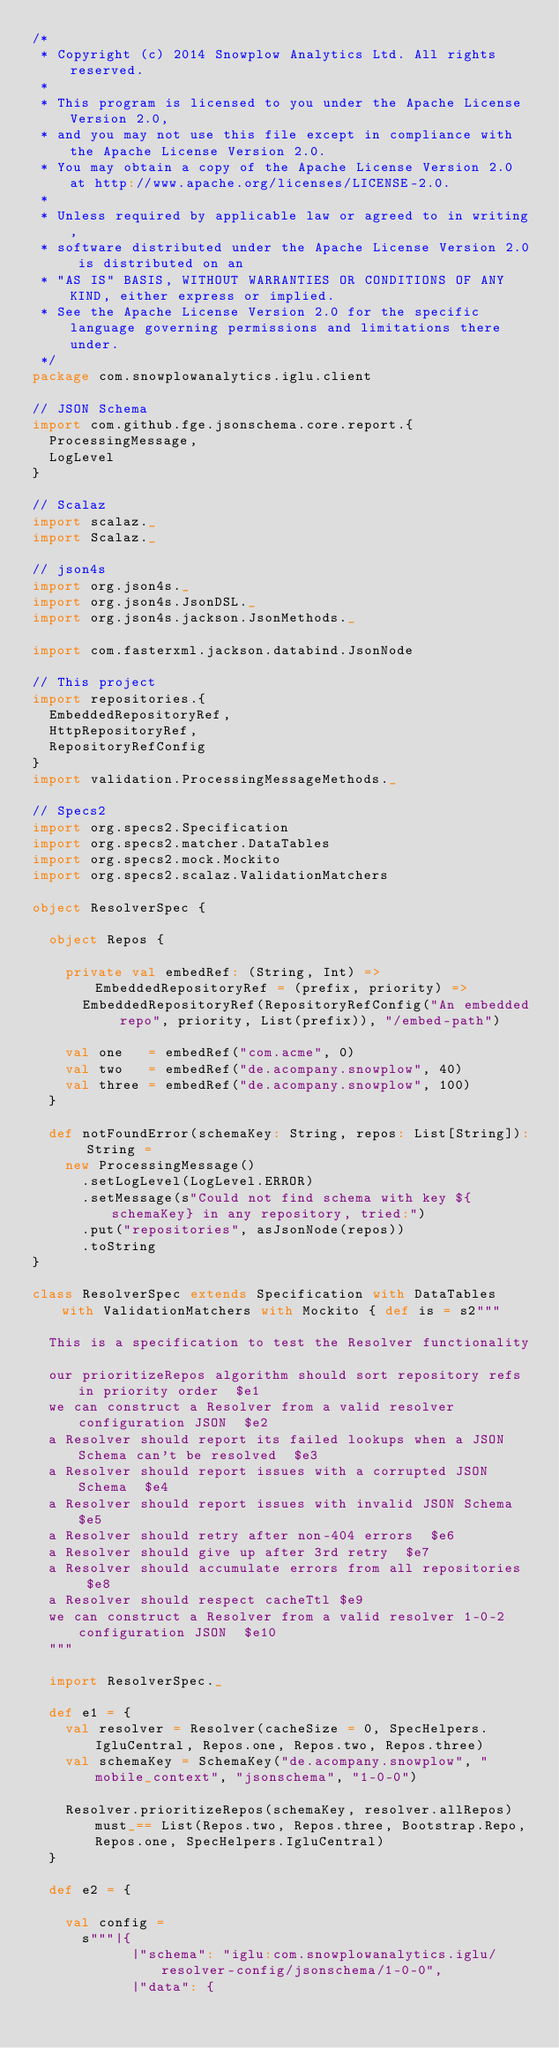Convert code to text. <code><loc_0><loc_0><loc_500><loc_500><_Scala_>/*
 * Copyright (c) 2014 Snowplow Analytics Ltd. All rights reserved.
 *
 * This program is licensed to you under the Apache License Version 2.0,
 * and you may not use this file except in compliance with the Apache License Version 2.0.
 * You may obtain a copy of the Apache License Version 2.0 at http://www.apache.org/licenses/LICENSE-2.0.
 *
 * Unless required by applicable law or agreed to in writing,
 * software distributed under the Apache License Version 2.0 is distributed on an
 * "AS IS" BASIS, WITHOUT WARRANTIES OR CONDITIONS OF ANY KIND, either express or implied.
 * See the Apache License Version 2.0 for the specific language governing permissions and limitations there under.
 */
package com.snowplowanalytics.iglu.client

// JSON Schema
import com.github.fge.jsonschema.core.report.{
  ProcessingMessage,
  LogLevel
}

// Scalaz
import scalaz._
import Scalaz._

// json4s
import org.json4s._
import org.json4s.JsonDSL._
import org.json4s.jackson.JsonMethods._

import com.fasterxml.jackson.databind.JsonNode

// This project
import repositories.{
  EmbeddedRepositoryRef,
  HttpRepositoryRef,
  RepositoryRefConfig
}
import validation.ProcessingMessageMethods._

// Specs2
import org.specs2.Specification
import org.specs2.matcher.DataTables
import org.specs2.mock.Mockito
import org.specs2.scalaz.ValidationMatchers

object ResolverSpec {

  object Repos { 

    private val embedRef: (String, Int) => EmbeddedRepositoryRef = (prefix, priority) =>
      EmbeddedRepositoryRef(RepositoryRefConfig("An embedded repo", priority, List(prefix)), "/embed-path")

    val one   = embedRef("com.acme", 0)
    val two   = embedRef("de.acompany.snowplow", 40)
    val three = embedRef("de.acompany.snowplow", 100)
  }

  def notFoundError(schemaKey: String, repos: List[String]): String =
    new ProcessingMessage()
      .setLogLevel(LogLevel.ERROR)
      .setMessage(s"Could not find schema with key ${schemaKey} in any repository, tried:")
      .put("repositories", asJsonNode(repos))
      .toString
}

class ResolverSpec extends Specification with DataTables with ValidationMatchers with Mockito { def is = s2"""

  This is a specification to test the Resolver functionality

  our prioritizeRepos algorithm should sort repository refs in priority order  $e1
  we can construct a Resolver from a valid resolver configuration JSON  $e2
  a Resolver should report its failed lookups when a JSON Schema can't be resolved  $e3
  a Resolver should report issues with a corrupted JSON Schema  $e4
  a Resolver should report issues with invalid JSON Schema  $e5
  a Resolver should retry after non-404 errors  $e6
  a Resolver should give up after 3rd retry  $e7
  a Resolver should accumulate errors from all repositories  $e8
  a Resolver should respect cacheTtl $e9
  we can construct a Resolver from a valid resolver 1-0-2 configuration JSON  $e10
  """

  import ResolverSpec._

  def e1 = {
    val resolver = Resolver(cacheSize = 0, SpecHelpers.IgluCentral, Repos.one, Repos.two, Repos.three)
    val schemaKey = SchemaKey("de.acompany.snowplow", "mobile_context", "jsonschema", "1-0-0")

    Resolver.prioritizeRepos(schemaKey, resolver.allRepos) must_== List(Repos.two, Repos.three, Bootstrap.Repo, Repos.one, SpecHelpers.IgluCentral)
  }

  def e2 = {

    val config = 
      s"""|{
            |"schema": "iglu:com.snowplowanalytics.iglu/resolver-config/jsonschema/1-0-0",
            |"data": {</code> 